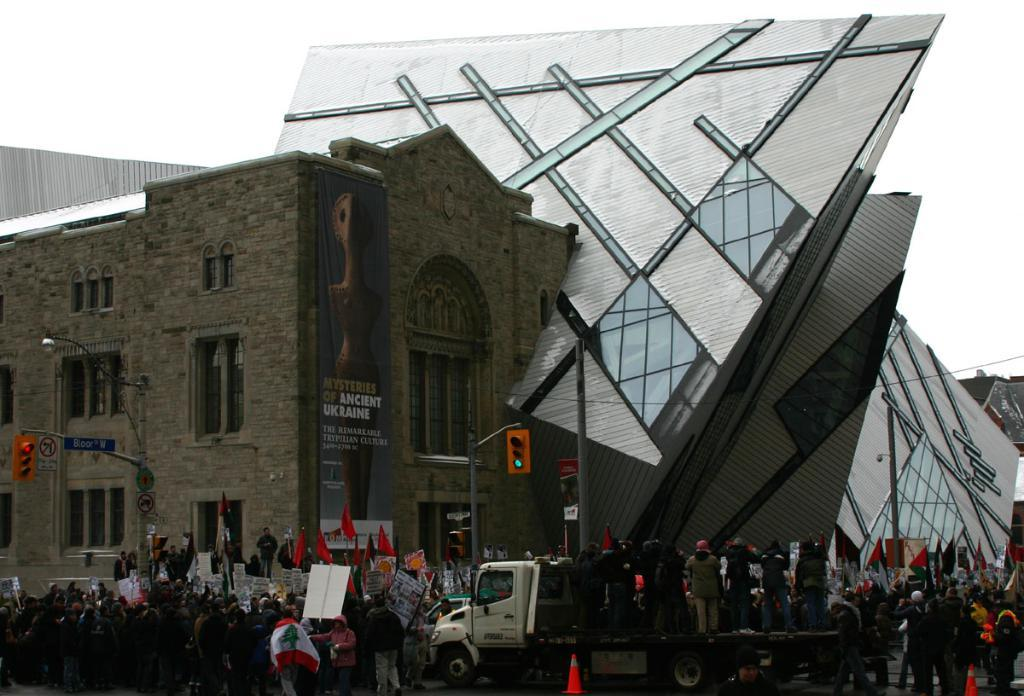What structure is located on the left side of the image? There is a building on the left side of the image. What activity involving people and a vehicle can be seen in the middle of the image? There are people standing on a vehicle in the middle of the image. How many locks are visible on the building in the image? There is no mention of locks on the building in the image. What type of connection can be seen between the people and the vehicle in the image? The image does not provide information about the type of connection between the people and the vehicle. Are there any spiders visible on the building or the vehicle in the image? There is no mention of spiders in the image. 